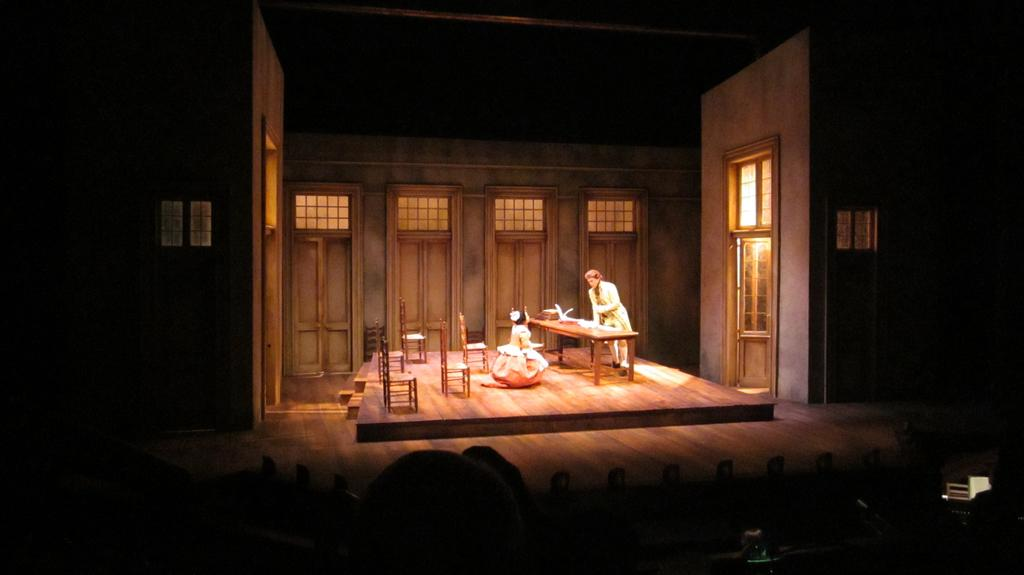Who or what is present in the image? There are people in the image. What type of furniture is in the image? There is a round table in the image. What is on the table? There are objects on the table. What can be used for sitting in the image? There are chairs in the image. What architectural feature is present in the image? There are doors in the image. What is visible at the bottom side of the image? There are objects visible at the bottom side of the image. What type of field is visible in the image? There is no field visible in the image. What kind of art can be seen on the walls in the image? There is no art visible on the walls in the image. 